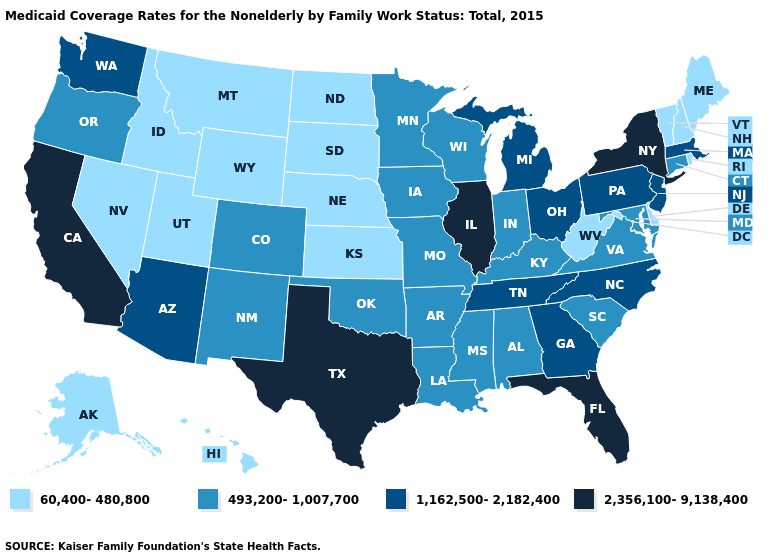What is the value of Georgia?
Write a very short answer. 1,162,500-2,182,400. Which states have the lowest value in the Northeast?
Be succinct. Maine, New Hampshire, Rhode Island, Vermont. Name the states that have a value in the range 60,400-480,800?
Concise answer only. Alaska, Delaware, Hawaii, Idaho, Kansas, Maine, Montana, Nebraska, Nevada, New Hampshire, North Dakota, Rhode Island, South Dakota, Utah, Vermont, West Virginia, Wyoming. What is the highest value in the USA?
Be succinct. 2,356,100-9,138,400. What is the value of South Dakota?
Keep it brief. 60,400-480,800. Does the map have missing data?
Give a very brief answer. No. Which states have the highest value in the USA?
Short answer required. California, Florida, Illinois, New York, Texas. Name the states that have a value in the range 493,200-1,007,700?
Concise answer only. Alabama, Arkansas, Colorado, Connecticut, Indiana, Iowa, Kentucky, Louisiana, Maryland, Minnesota, Mississippi, Missouri, New Mexico, Oklahoma, Oregon, South Carolina, Virginia, Wisconsin. How many symbols are there in the legend?
Give a very brief answer. 4. Among the states that border Tennessee , does Mississippi have the highest value?
Concise answer only. No. Name the states that have a value in the range 1,162,500-2,182,400?
Write a very short answer. Arizona, Georgia, Massachusetts, Michigan, New Jersey, North Carolina, Ohio, Pennsylvania, Tennessee, Washington. Does the map have missing data?
Answer briefly. No. How many symbols are there in the legend?
Quick response, please. 4. Does South Dakota have the lowest value in the MidWest?
Write a very short answer. Yes. Does Colorado have the lowest value in the USA?
Short answer required. No. 